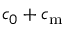<formula> <loc_0><loc_0><loc_500><loc_500>c _ { 0 } + c _ { m }</formula> 